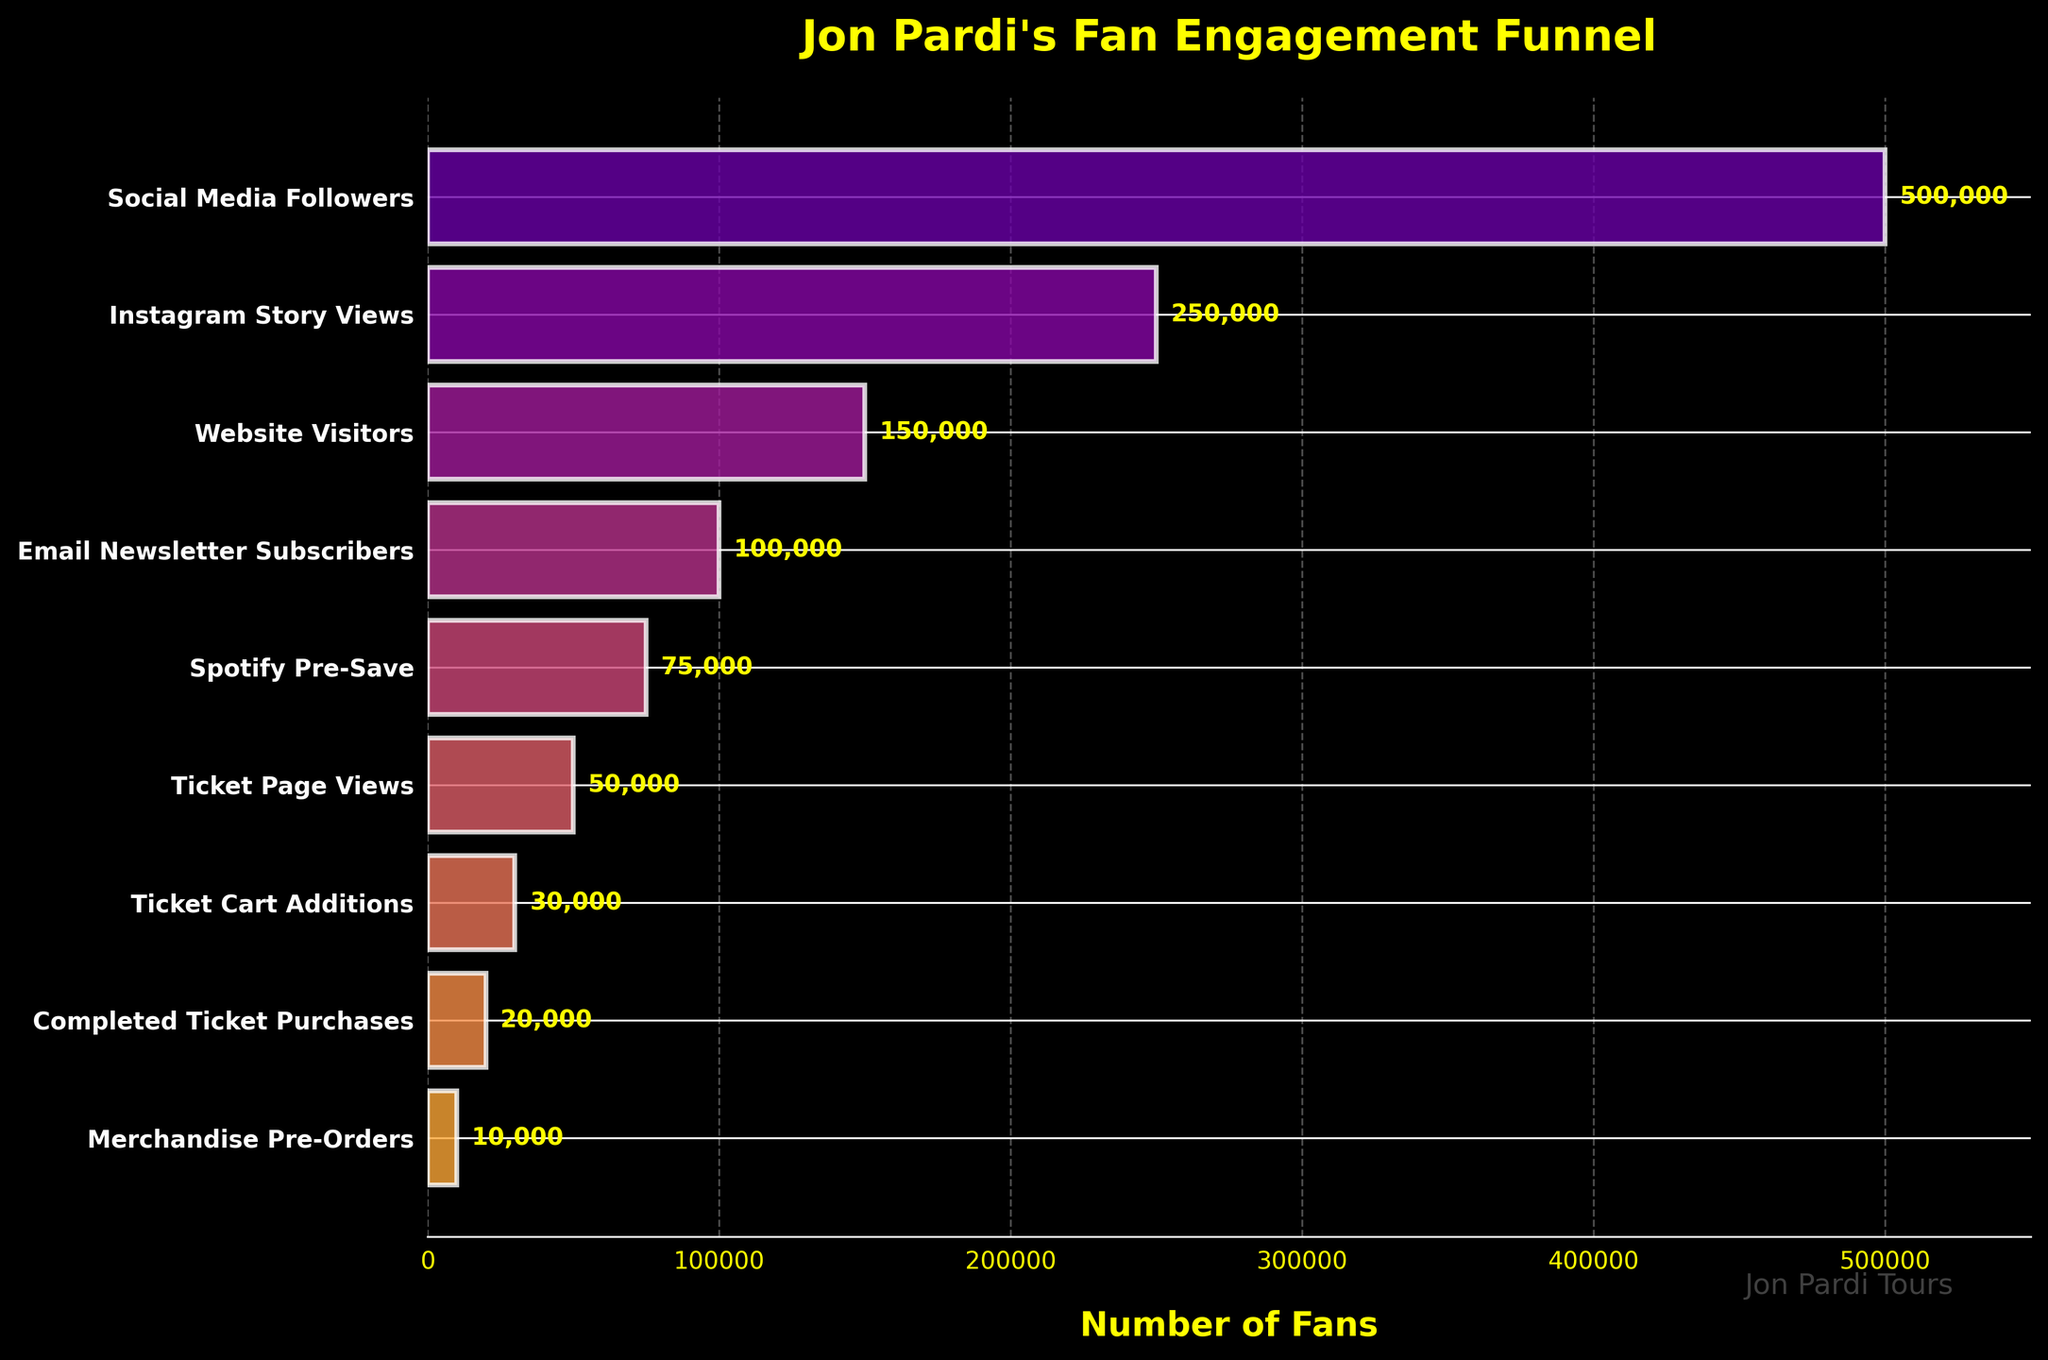How many stages are shown in the funnel chart? Count the number of stages listed on the y-axis in the chart. There are 9 stages from "Social Media Followers" to "Merchandise Pre-Orders".
Answer: 9 What is the title of the funnel chart? Look at the top of the chart where the title is displayed. The title is "Jon Pardi's Fan Engagement Funnel".
Answer: Jon Pardi's Fan Engagement Funnel Which stage has the highest number of fans? Identify the stage with the longest bar, representing the highest number of fans. "Social Media Followers" has the highest number of fans at 500,000.
Answer: Social Media Followers Which two stages have the smallest difference in fan numbers? Compare the differences between stages by subtracting the number of fans of each consecutive stage. The smallest difference is between "Ticket Cart Additions" (30,000) and "Completed Ticket Purchases" (20,000), having a difference of 10,000.
Answer: Ticket Cart Additions and Completed Ticket Purchases What is the percentage drop in fans from "Social Media Followers" to "Instagram Story Views"? Subtract the number of "Instagram Story Views" fans from "Social Media Followers" fans, divide by the number of "Social Media Followers" fans, and multiply by 100. The calculation is ((500,000 - 250,000) / 500,000) * 100 = 50%.
Answer: 50% What is the cumulative number of fans from "Website Visitors" to "Completed Ticket Purchases"? Sum the number of fans in each stage from "Website Visitors" to "Completed Ticket Purchases". The calculation is 150,000 + 100,000 + 75,000 + 50,000 + 30,000 + 20,000 = 425,000.
Answer: 425,000 By how many fans does the number of "Spotify Pre-Save" exceed "Merchandise Pre-Orders"? Subtract the number of fans at "Merchandise Pre-Orders" from "Spotify Pre-Save". The calculation is 75,000 - 10,000 = 65,000.
Answer: 65,000 How does the number of "Ticket Page Views" compare to "Email Newsletter Subscribers"? Compare the fans at both levels. "Ticket Page Views" has 50,000 fans, while "Email Newsletter Subscribers" has 100,000 fans, which is double the amount.
Answer: "Ticket Page Views" has half the fans as "Email Newsletter Subscribers" What is the average number of fans across all stages? Sum the number of fans in all stages and divide by the number of stages. The calculation is (500,000 + 250,000 + 150,000 + 100,000 + 75,000 + 50,000 + 30,000 + 20,000 + 10,000) / 9 ≈ 131,667.
Answer: 131,667 